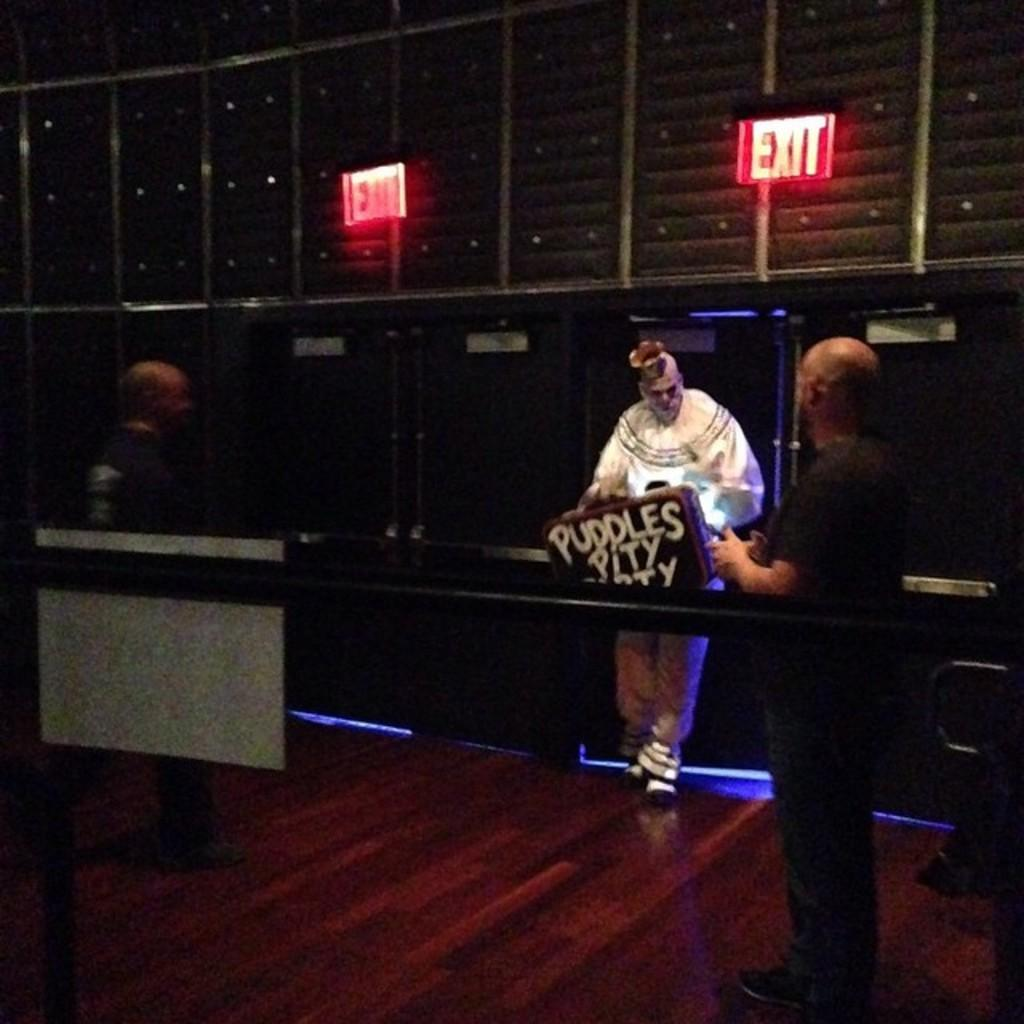How many people are in the image? There are three people in the image. What are the people wearing? The people are wearing dresses. Can you describe any objects with writing in the image? Yes, there is an object with writing on it in the image. What can be seen on the wall in the background of the image? There are LED boards on the wall in the background of the image. What type of smile can be seen on the harbor in the image? There is no harbor present in the image, and therefore no smile can be seen on it. 